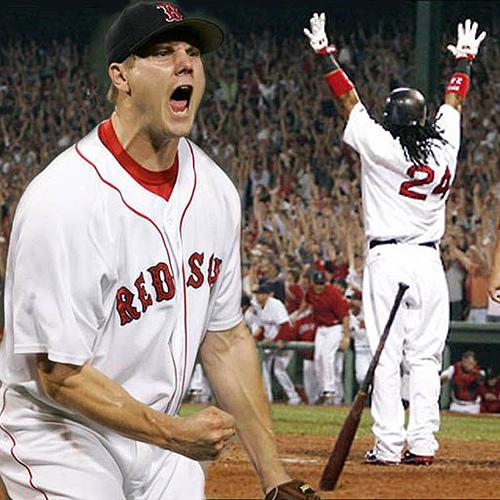What color are the player on right's gloves?
Give a very brief answer. White. What team do these players play for?
Short answer required. Red sox. Why is the player celebrating?
Be succinct. Home run. 